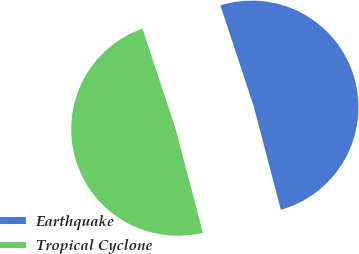<chart> <loc_0><loc_0><loc_500><loc_500><pie_chart><fcel>Earthquake<fcel>Tropical Cyclone<nl><fcel>50.99%<fcel>49.01%<nl></chart> 